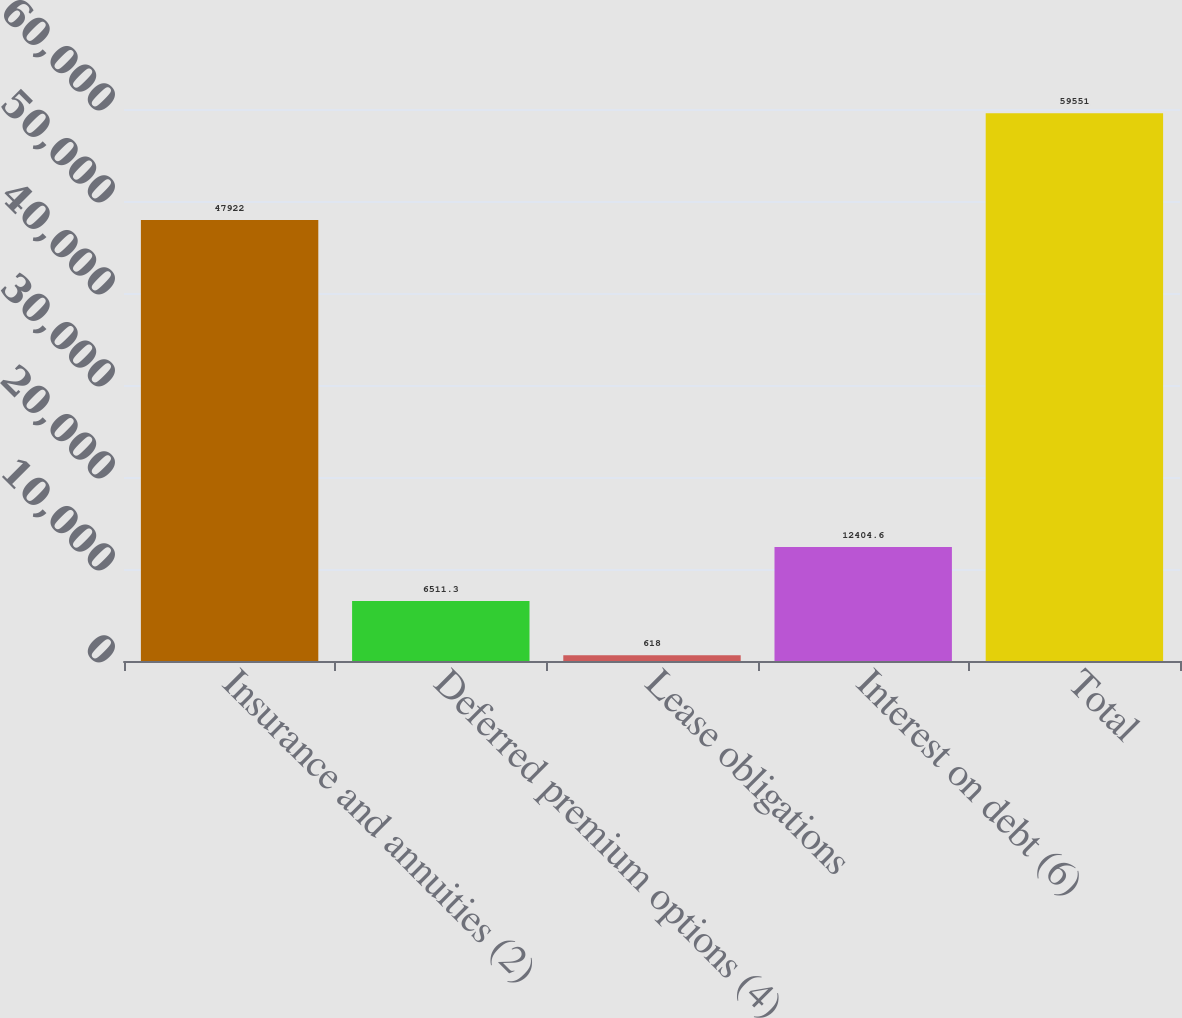Convert chart. <chart><loc_0><loc_0><loc_500><loc_500><bar_chart><fcel>Insurance and annuities (2)<fcel>Deferred premium options (4)<fcel>Lease obligations<fcel>Interest on debt (6)<fcel>Total<nl><fcel>47922<fcel>6511.3<fcel>618<fcel>12404.6<fcel>59551<nl></chart> 